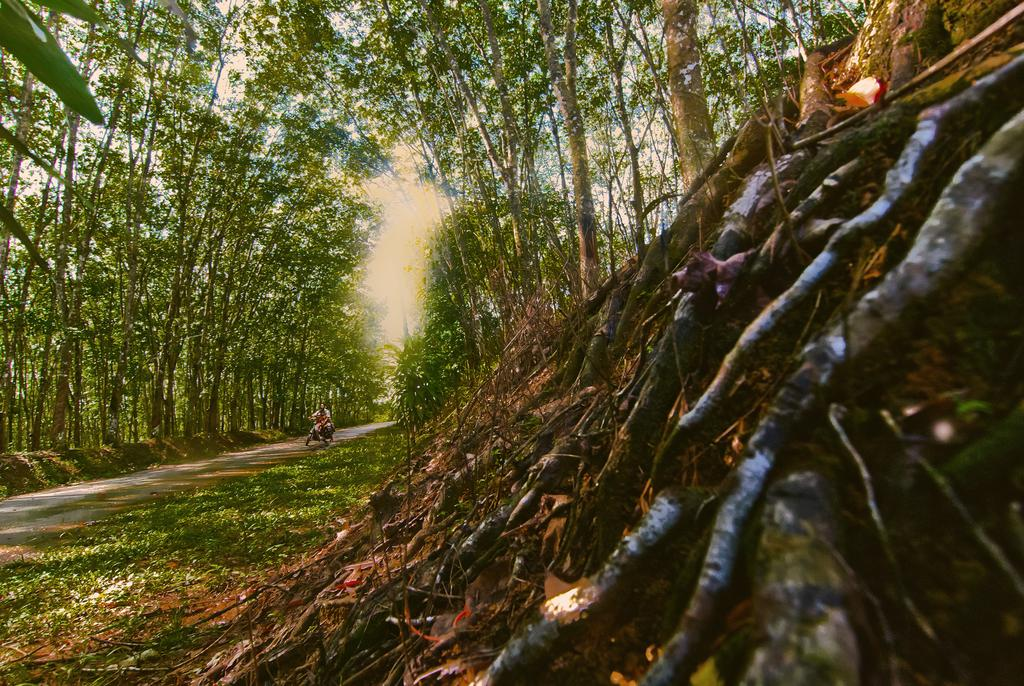What is the person in the image doing? There is a person sitting on a motorcycle in the image. How is the motorcycle positioned in the image? The motorcycle is parked on the ground. What can be seen in the background of the image? There are trees and the sky visible in the background of the image. How many oranges are hanging from the trees in the image? There are no oranges visible in the image; only trees and the sky are present in the background. 